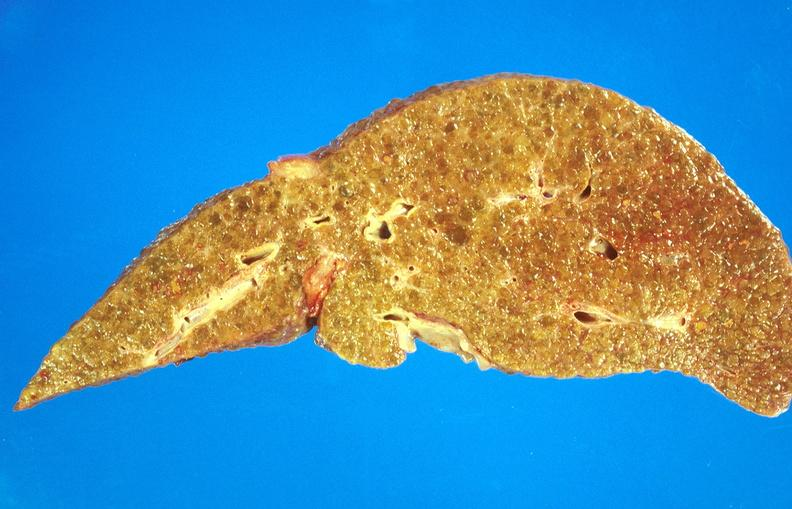does this image show alcoholic cirrhosis?
Answer the question using a single word or phrase. Yes 